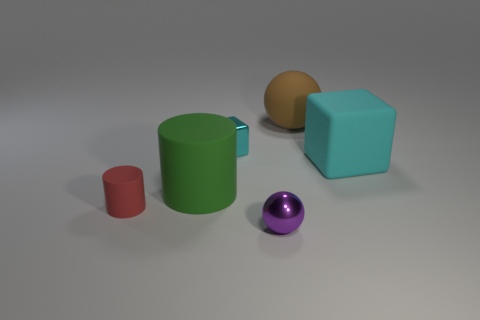What is the material of the small block?
Ensure brevity in your answer.  Metal. There is a small cyan metallic object; what number of rubber blocks are to the right of it?
Offer a terse response. 1. Is the material of the big brown object that is on the right side of the purple sphere the same as the tiny cyan block?
Provide a succinct answer. No. What number of small red matte things are the same shape as the green thing?
Offer a terse response. 1. How many big things are purple shiny cylinders or purple balls?
Provide a short and direct response. 0. Do the shiny object left of the tiny metal sphere and the large block have the same color?
Your answer should be compact. Yes. Is the color of the small metal cube that is behind the green object the same as the block on the right side of the tiny cube?
Your response must be concise. Yes. Are there any big brown spheres that have the same material as the large block?
Give a very brief answer. Yes. How many gray things are tiny things or large things?
Give a very brief answer. 0. Are there more objects in front of the big ball than green cylinders?
Provide a short and direct response. Yes. 